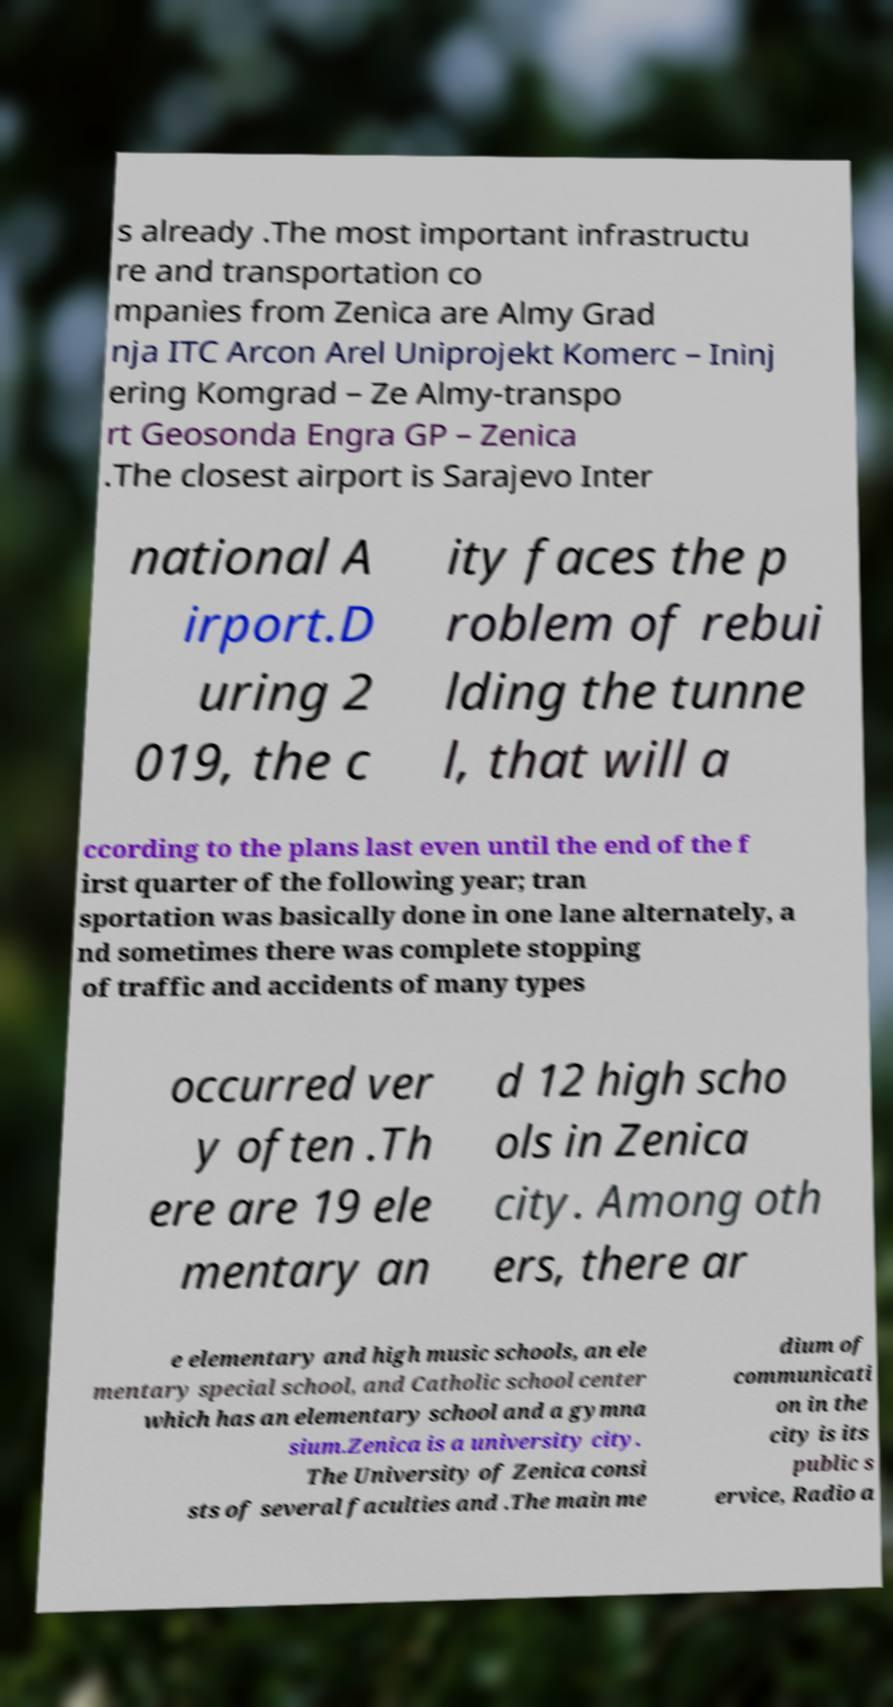Can you accurately transcribe the text from the provided image for me? s already .The most important infrastructu re and transportation co mpanies from Zenica are Almy Grad nja ITC Arcon Arel Uniprojekt Komerc – Ininj ering Komgrad – Ze Almy-transpo rt Geosonda Engra GP – Zenica .The closest airport is Sarajevo Inter national A irport.D uring 2 019, the c ity faces the p roblem of rebui lding the tunne l, that will a ccording to the plans last even until the end of the f irst quarter of the following year; tran sportation was basically done in one lane alternately, a nd sometimes there was complete stopping of traffic and accidents of many types occurred ver y often .Th ere are 19 ele mentary an d 12 high scho ols in Zenica city. Among oth ers, there ar e elementary and high music schools, an ele mentary special school, and Catholic school center which has an elementary school and a gymna sium.Zenica is a university city. The University of Zenica consi sts of several faculties and .The main me dium of communicati on in the city is its public s ervice, Radio a 